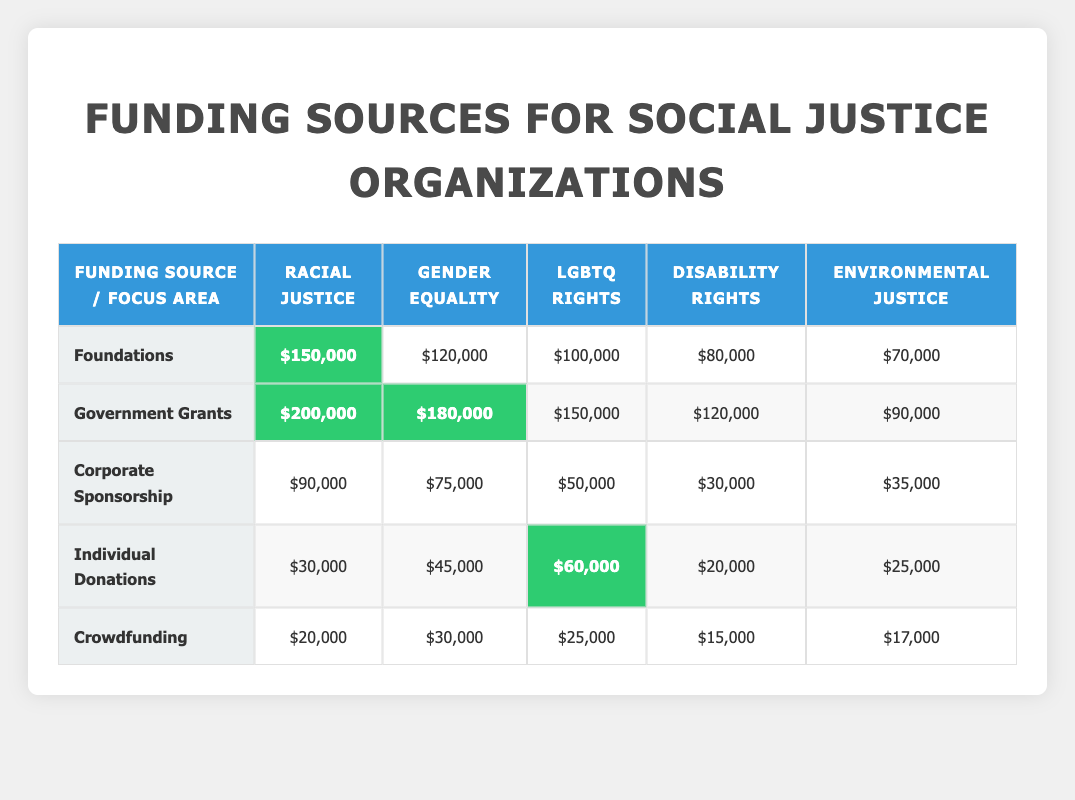What is the highest source of funding for racial justice? The table indicates that the government grants are $200,000 for racial justice, which is greater than all other sources.
Answer: $200,000 Which category received the least funding from corporate sponsorship? Looking at the corporate sponsorship row, the disability rights category received the least funding, which is $30,000.
Answer: $30,000 What is the total funding for gender equality across all sources? To find the total funding for gender equality, we add the values from all sources: $120,000 (foundations) + $180,000 (government grants) + $75,000 (corporate sponsorship) + $45,000 (individual donations) + $30,000 (crowdfunding) = $450,000.
Answer: $450,000 Is the total funding for environmental justice more than the total funding for disability rights? First, we find the total for each category: Environmental justice totals to $70,000 + $90,000 + $35,000 + $25,000 + $17,000 = $237,000. Disability rights totals to $80,000 + $120,000 + $30,000 + $20,000 + $15,000 = $265,000. Since 237,000 is less than 265,000, the answer is no.
Answer: No Which demographic focus area received the highest funding from individual donations? In the individual donations row, LGBTQ rights received the highest funding at $60,000 compared to other categories.
Answer: $60,000 What is the difference in funding between the highest and lowest sources for environmental justice? The funding for environmental justice from government grants is the highest at $90,000, while the lowest source, corporate sponsorship, is $35,000. The difference is calculated as $90,000 - $35,000 = $55,000.
Answer: $55,000 Did foundations provide more funding for racial justice than for gender equality? Foundations provided $150,000 for racial justice and $120,000 for gender equality. Since 150,000 is greater than 120,000, the answer is yes.
Answer: Yes What is the average funding for LGBTQ rights across all sources? To find the average, add all funding values for LGBTQ rights: $100,000 + $150,000 + $50,000 + $60,000 + $25,000 = $385,000. Then divide by the number of sources (5): $385,000 / 5 = $77,000.
Answer: $77,000 